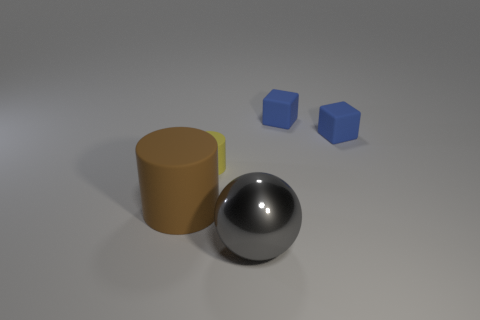Add 1 large cyan shiny cubes. How many objects exist? 6 Subtract all cylinders. How many objects are left? 3 Add 1 yellow metal spheres. How many yellow metal spheres exist? 1 Subtract 0 purple cubes. How many objects are left? 5 Subtract all small rubber objects. Subtract all shiny spheres. How many objects are left? 1 Add 5 cylinders. How many cylinders are left? 7 